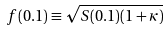Convert formula to latex. <formula><loc_0><loc_0><loc_500><loc_500>f ( 0 . 1 ) \equiv \sqrt { S ( 0 . 1 ) ( 1 + \kappa ) }</formula> 